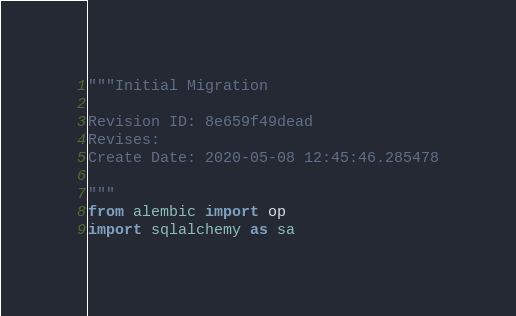<code> <loc_0><loc_0><loc_500><loc_500><_Python_>"""Initial Migration

Revision ID: 8e659f49dead
Revises: 
Create Date: 2020-05-08 12:45:46.285478

"""
from alembic import op
import sqlalchemy as sa

</code> 